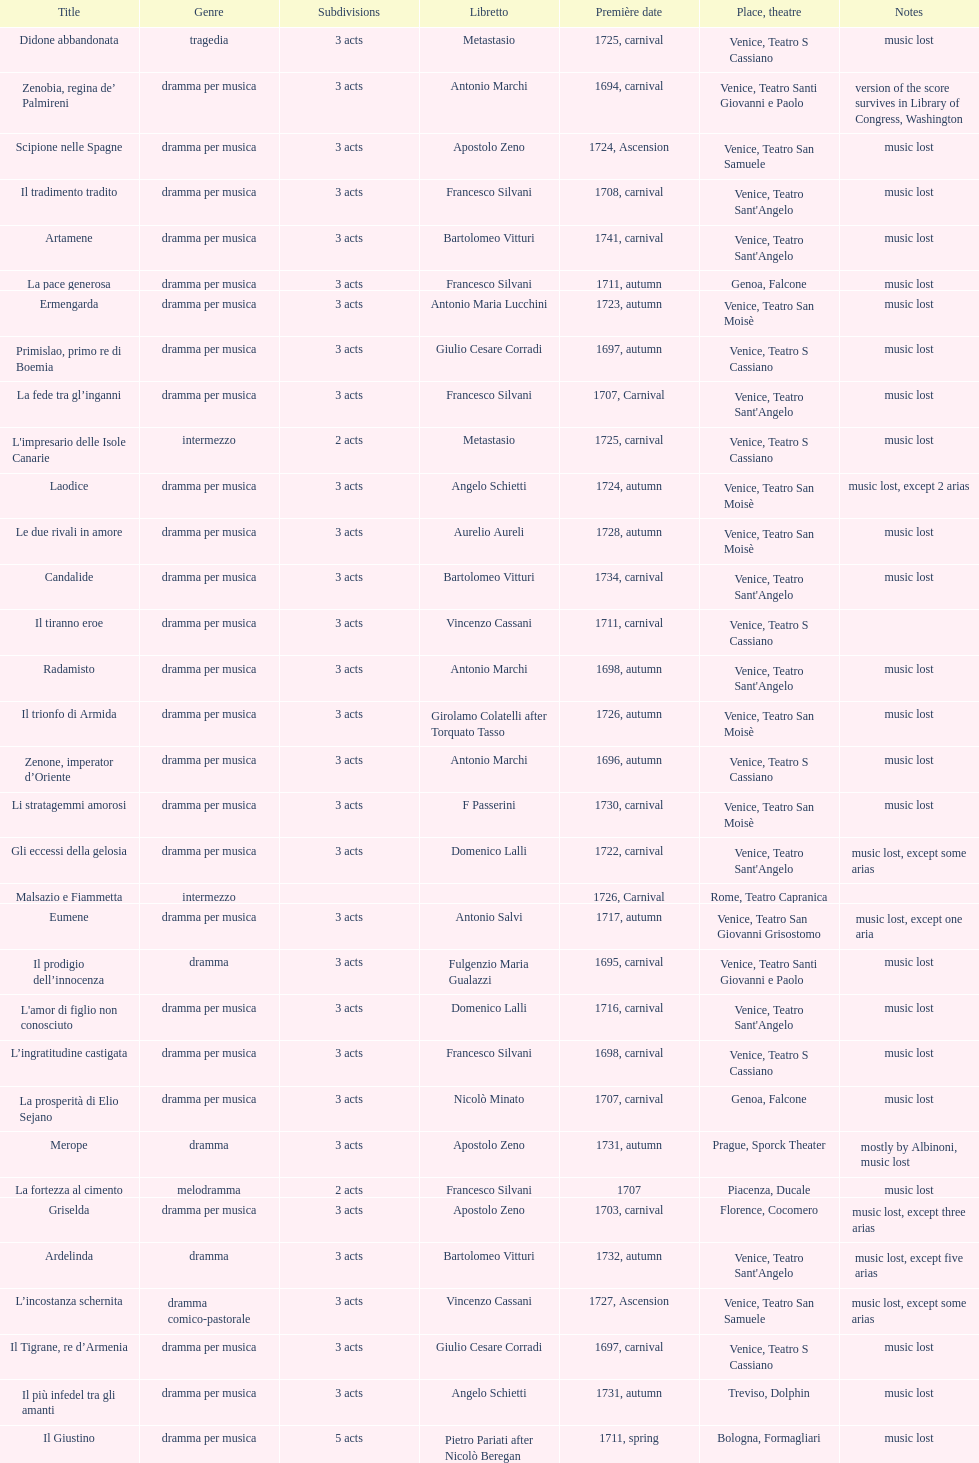How many were released after zenone, imperator d'oriente? 52. 